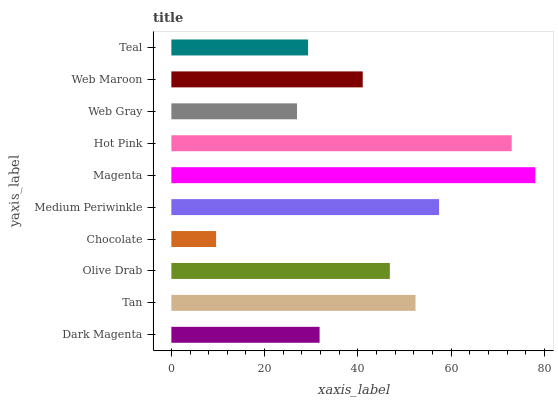Is Chocolate the minimum?
Answer yes or no. Yes. Is Magenta the maximum?
Answer yes or no. Yes. Is Tan the minimum?
Answer yes or no. No. Is Tan the maximum?
Answer yes or no. No. Is Tan greater than Dark Magenta?
Answer yes or no. Yes. Is Dark Magenta less than Tan?
Answer yes or no. Yes. Is Dark Magenta greater than Tan?
Answer yes or no. No. Is Tan less than Dark Magenta?
Answer yes or no. No. Is Olive Drab the high median?
Answer yes or no. Yes. Is Web Maroon the low median?
Answer yes or no. Yes. Is Magenta the high median?
Answer yes or no. No. Is Magenta the low median?
Answer yes or no. No. 